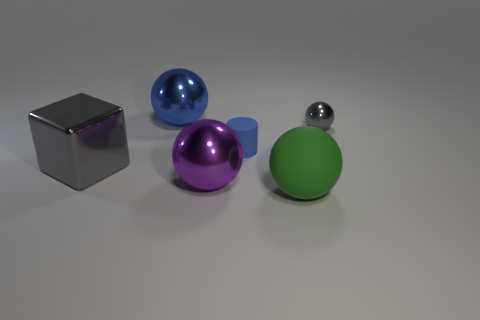Add 1 blue cubes. How many objects exist? 7 Subtract all cylinders. How many objects are left? 5 Add 1 large purple objects. How many large purple objects exist? 2 Subtract 0 brown blocks. How many objects are left? 6 Subtract all large rubber objects. Subtract all metal spheres. How many objects are left? 2 Add 6 small balls. How many small balls are left? 7 